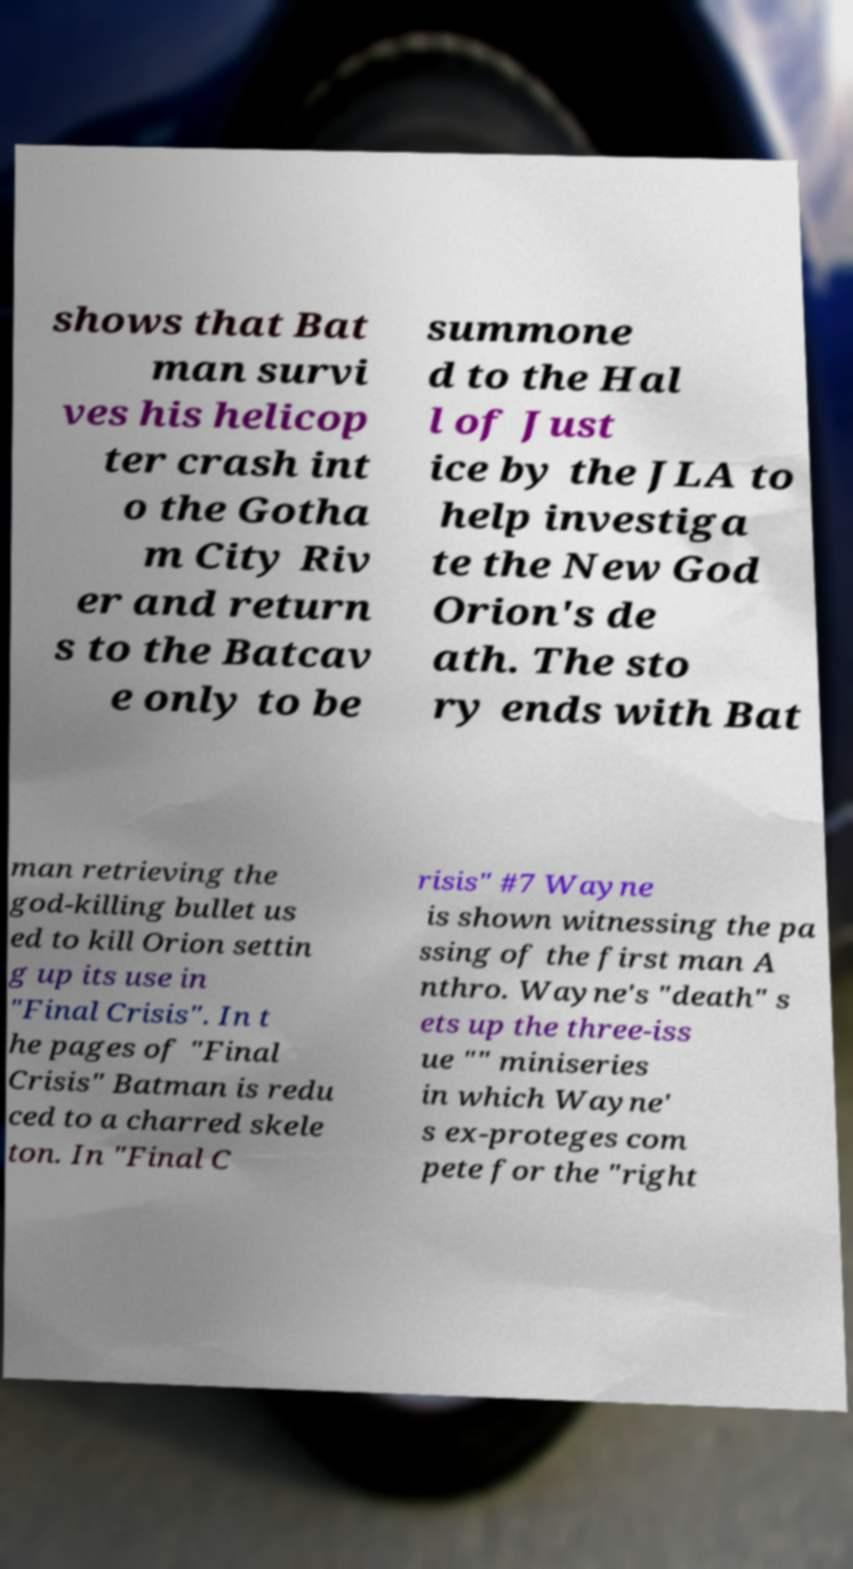Can you accurately transcribe the text from the provided image for me? shows that Bat man survi ves his helicop ter crash int o the Gotha m City Riv er and return s to the Batcav e only to be summone d to the Hal l of Just ice by the JLA to help investiga te the New God Orion's de ath. The sto ry ends with Bat man retrieving the god-killing bullet us ed to kill Orion settin g up its use in "Final Crisis". In t he pages of "Final Crisis" Batman is redu ced to a charred skele ton. In "Final C risis" #7 Wayne is shown witnessing the pa ssing of the first man A nthro. Wayne's "death" s ets up the three-iss ue "" miniseries in which Wayne' s ex-proteges com pete for the "right 